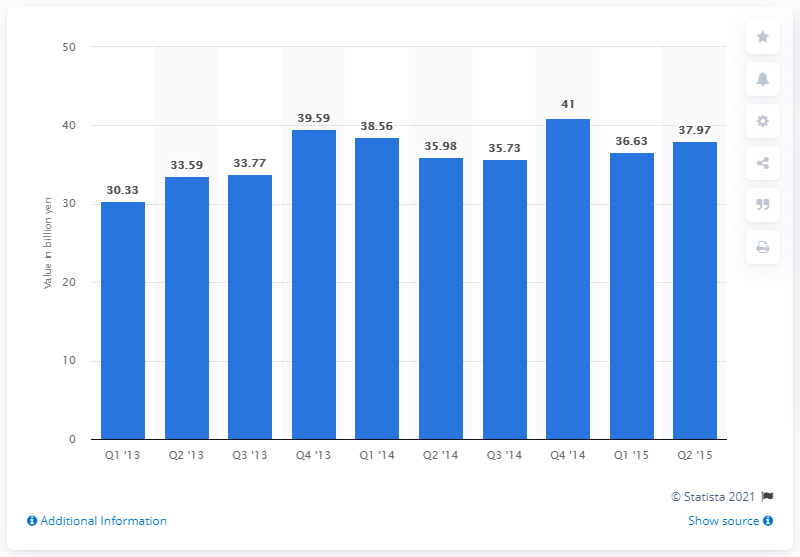Give some essential details in this illustration. Rakuten Ichiba's sales volume in the most recent quarter was 37.97. 